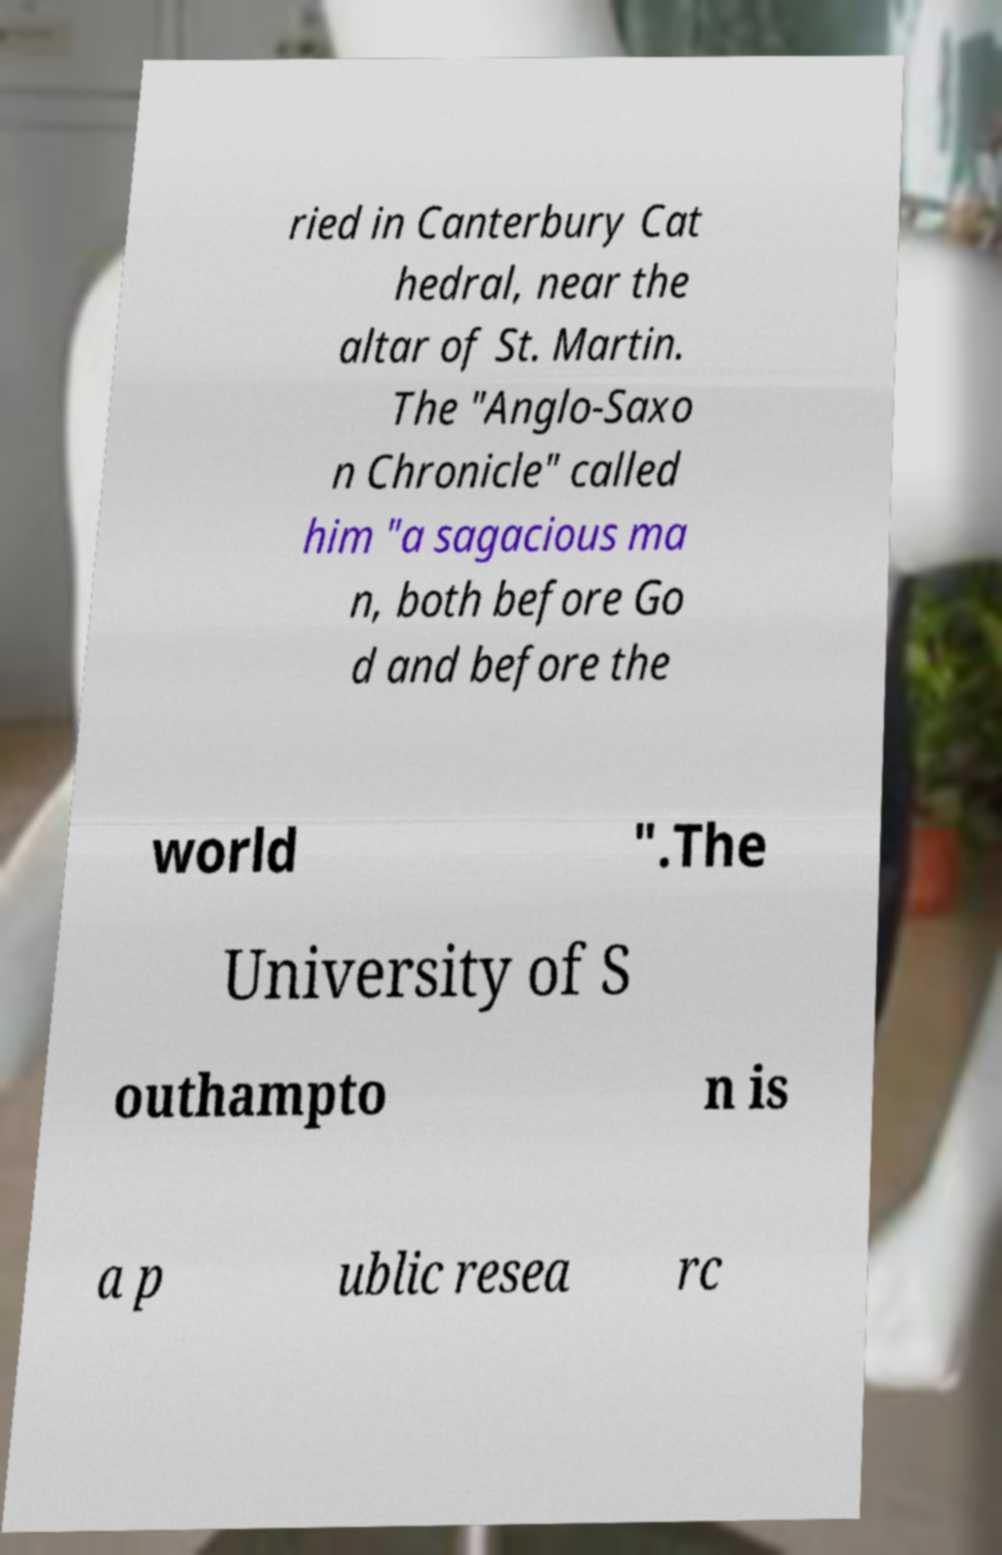Could you assist in decoding the text presented in this image and type it out clearly? ried in Canterbury Cat hedral, near the altar of St. Martin. The "Anglo-Saxo n Chronicle" called him "a sagacious ma n, both before Go d and before the world ".The University of S outhampto n is a p ublic resea rc 